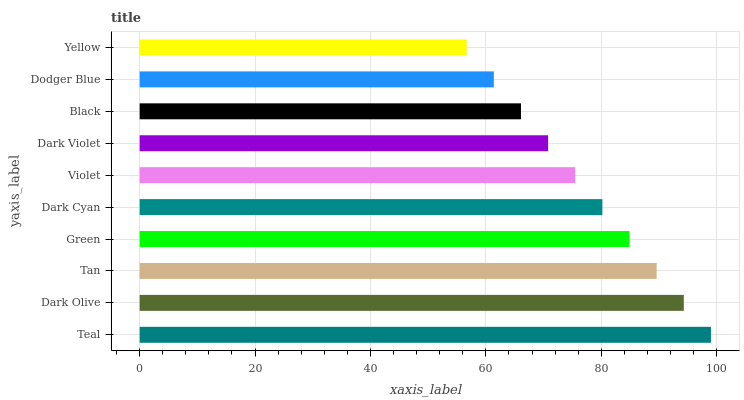Is Yellow the minimum?
Answer yes or no. Yes. Is Teal the maximum?
Answer yes or no. Yes. Is Dark Olive the minimum?
Answer yes or no. No. Is Dark Olive the maximum?
Answer yes or no. No. Is Teal greater than Dark Olive?
Answer yes or no. Yes. Is Dark Olive less than Teal?
Answer yes or no. Yes. Is Dark Olive greater than Teal?
Answer yes or no. No. Is Teal less than Dark Olive?
Answer yes or no. No. Is Dark Cyan the high median?
Answer yes or no. Yes. Is Violet the low median?
Answer yes or no. Yes. Is Dark Olive the high median?
Answer yes or no. No. Is Dark Violet the low median?
Answer yes or no. No. 